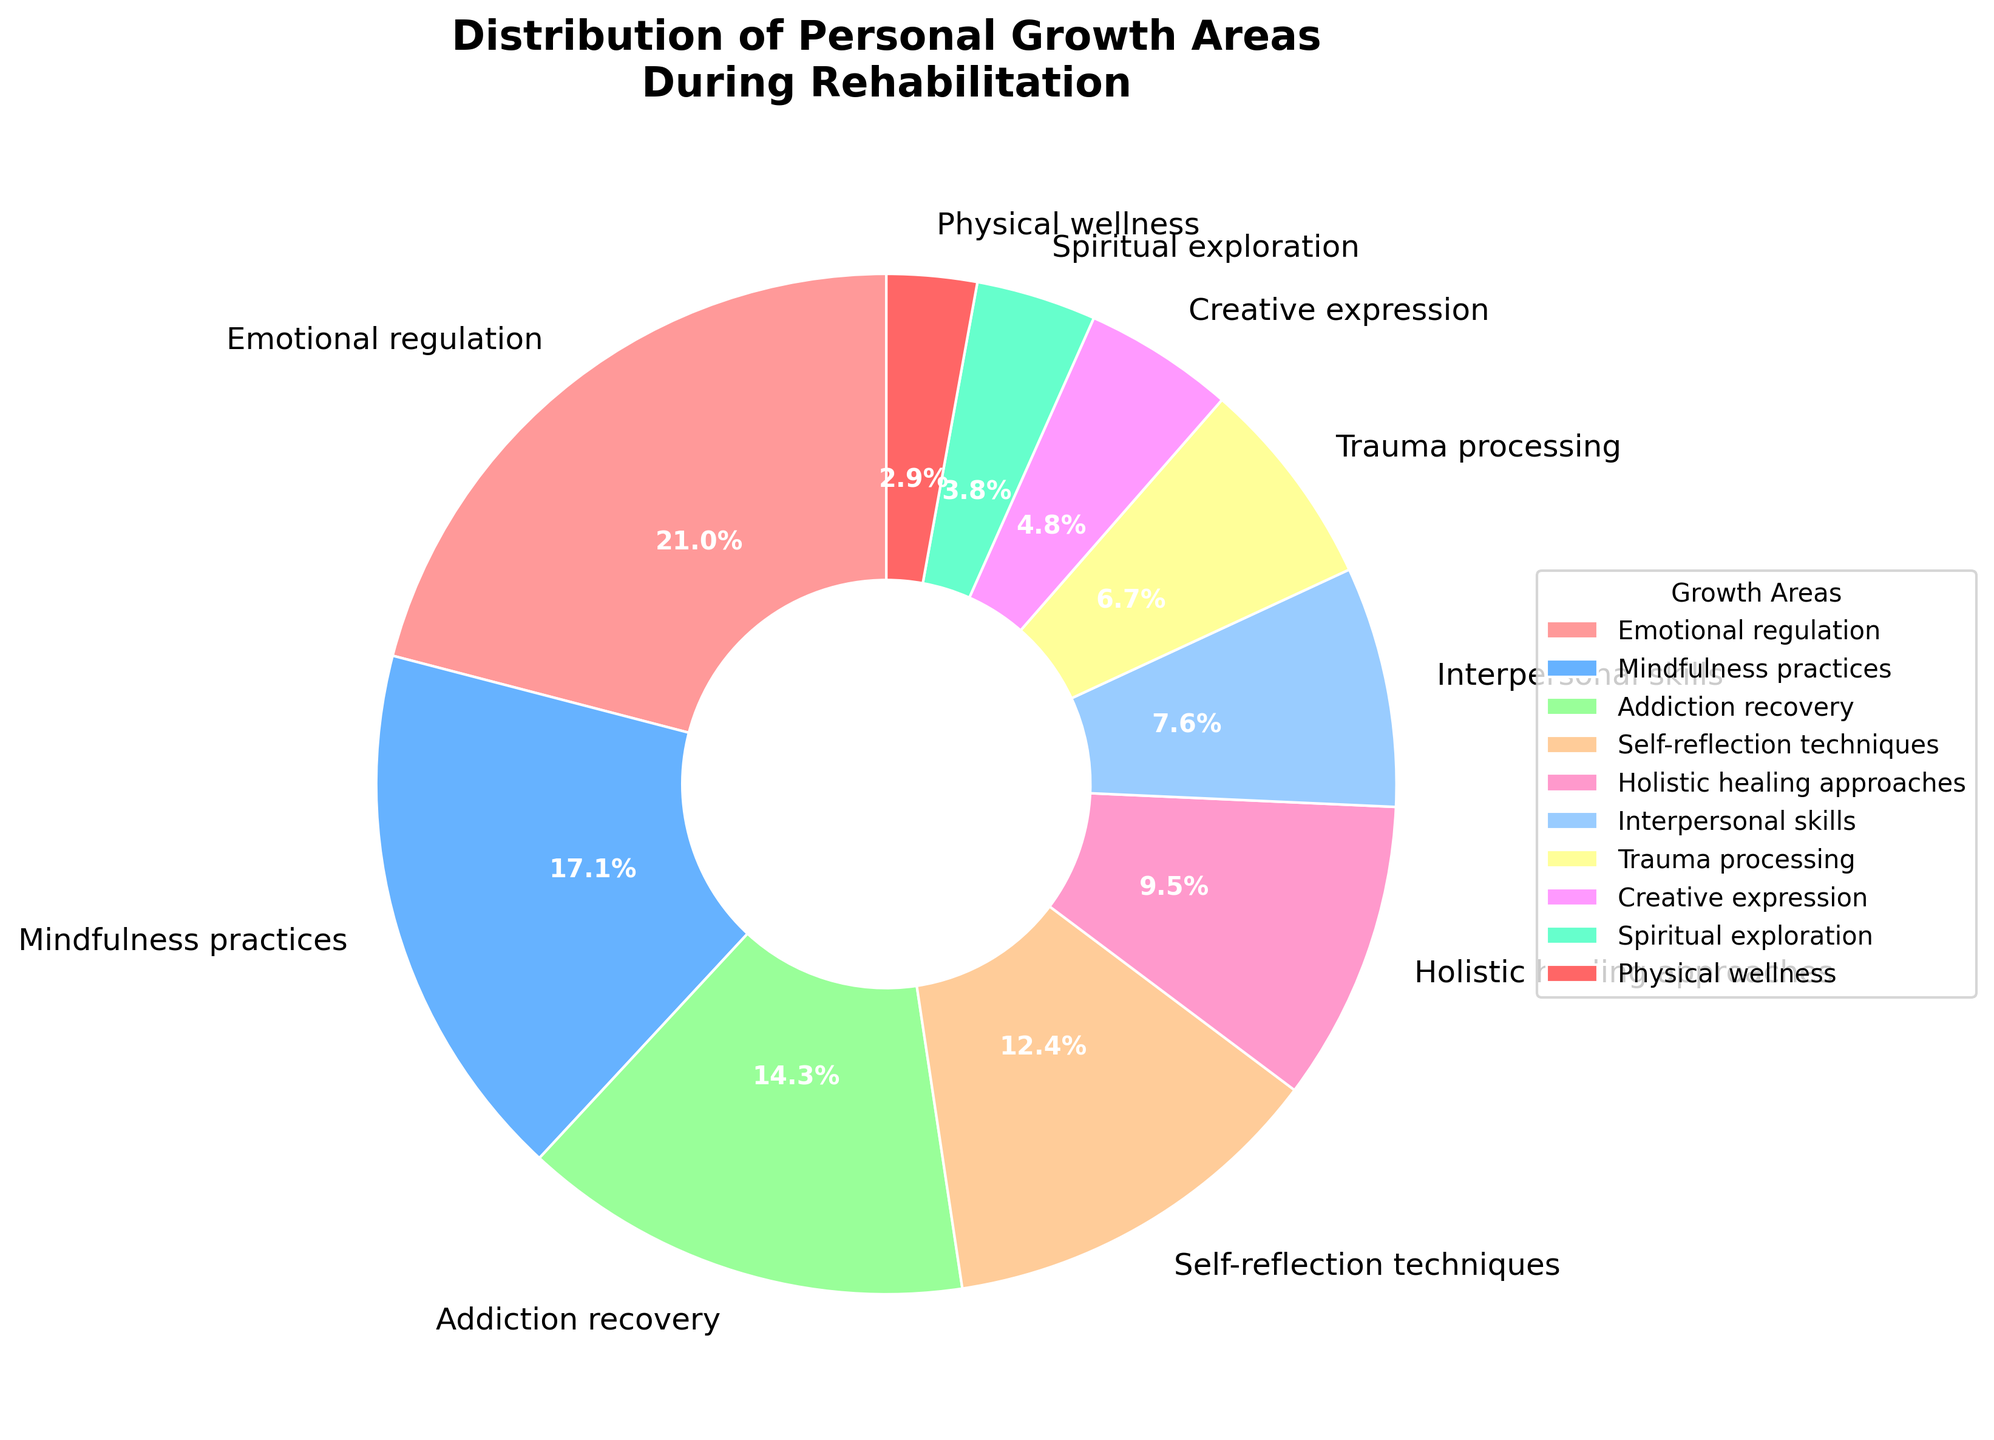What's the largest area of focus during rehabilitation? The largest segment in the pie chart is labeled "Emotional regulation" with 22%. This is the biggest portion of the pie, making it the largest area of focus.
Answer: Emotional regulation What's the combined percentage of Addiction recovery and Self-reflection techniques? The percentage for "Addiction recovery" is 15% and for "Self-reflection techniques" is 13%. Adding these together, 15% + 13% = 28%.
Answer: 28% How does the percentage of Mindfulness practices compare to that of Holistic healing approaches? "Mindfulness practices" is shown at 18%, while "Holistic healing approaches" is at 10%. The percentage of Mindfulness practices is greater than that of Holistic healing approaches.
Answer: Mindfulness practices is greater Which area has the smallest focus and what is its percentage? The smallest portion of the pie chart is labeled "Physical wellness" with 3%. This is the smallest area of focus.
Answer: Physical wellness with 3% What is the total percentage of areas with less than 10% focus each? Areas with less than 10% focus each are "Interpersonal skills" (8%), "Trauma processing" (7%), "Creative expression" (5%), "Spiritual exploration" (4%), and "Physical wellness" (3%). Adding these together, 8% + 7% + 5% + 4% + 3% = 27%.
Answer: 27% Is the percentage of Trauma processing closer to that of Interpersonal skills or Physical wellness? "Trauma processing" has 7%, "Interpersonal skills" has 8%, and "Physical wellness" has 3%. The difference between Trauma processing and Interpersonal skills is 1% (8% - 7%), whereas the difference between Trauma processing and Physical wellness is 4% (7% - 3%). So, Trauma processing is closer to Interpersonal skills.
Answer: Interpersonal skills What is the difference in percentage between Creative expression and Spiritual exploration? "Creative expression" is at 5% and "Spiritual exploration" is at 4%. The difference is 1% (5% - 4%).
Answer: 1% Which areas' combined percentage make up the largest share: Emotional regulation and Mindfulness practices or Addiction recovery and Self-reflection techniques? The combined percentage for "Emotional regulation" (22%) and "Mindfulness practices" (18%) is 40%. For "Addiction recovery" (15%) and "Self-reflection techniques" (13%), it is 28%. Since 40% is greater than 28%, Emotional regulation and Mindfulness practices combined make up the largest share.
Answer: Emotional regulation and Mindfulness practices 